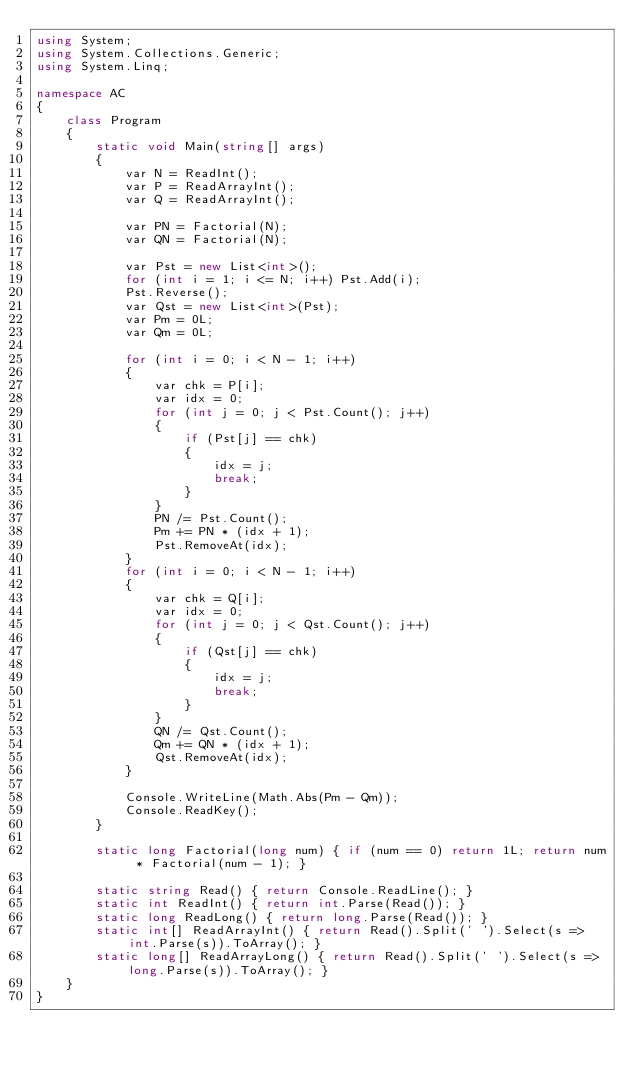Convert code to text. <code><loc_0><loc_0><loc_500><loc_500><_C#_>using System;
using System.Collections.Generic;
using System.Linq;

namespace AC
{
    class Program
    {
        static void Main(string[] args)
        {
            var N = ReadInt();
            var P = ReadArrayInt();
            var Q = ReadArrayInt();

            var PN = Factorial(N);
            var QN = Factorial(N);

            var Pst = new List<int>();
            for (int i = 1; i <= N; i++) Pst.Add(i);
            Pst.Reverse();
            var Qst = new List<int>(Pst);
            var Pm = 0L;
            var Qm = 0L;

            for (int i = 0; i < N - 1; i++)
            {
                var chk = P[i];
                var idx = 0;
                for (int j = 0; j < Pst.Count(); j++)
                {
                    if (Pst[j] == chk)
                    {
                        idx = j;
                        break;
                    }
                }
                PN /= Pst.Count();
                Pm += PN * (idx + 1);
                Pst.RemoveAt(idx);
            }
            for (int i = 0; i < N - 1; i++)
            {
                var chk = Q[i];
                var idx = 0;
                for (int j = 0; j < Qst.Count(); j++)
                {
                    if (Qst[j] == chk)
                    {
                        idx = j;
                        break;
                    }
                }
                QN /= Qst.Count();
                Qm += QN * (idx + 1);
                Qst.RemoveAt(idx);
            }

            Console.WriteLine(Math.Abs(Pm - Qm));
            Console.ReadKey();
        }

        static long Factorial(long num) { if (num == 0) return 1L; return num * Factorial(num - 1); }

        static string Read() { return Console.ReadLine(); }
        static int ReadInt() { return int.Parse(Read()); }
        static long ReadLong() { return long.Parse(Read()); }
        static int[] ReadArrayInt() { return Read().Split(' ').Select(s => int.Parse(s)).ToArray(); }
        static long[] ReadArrayLong() { return Read().Split(' ').Select(s => long.Parse(s)).ToArray(); }
    }
}</code> 